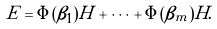<formula> <loc_0><loc_0><loc_500><loc_500>E = \Phi ( \beta _ { 1 } ) H + \dots + \Phi ( \beta _ { m } ) H .</formula> 